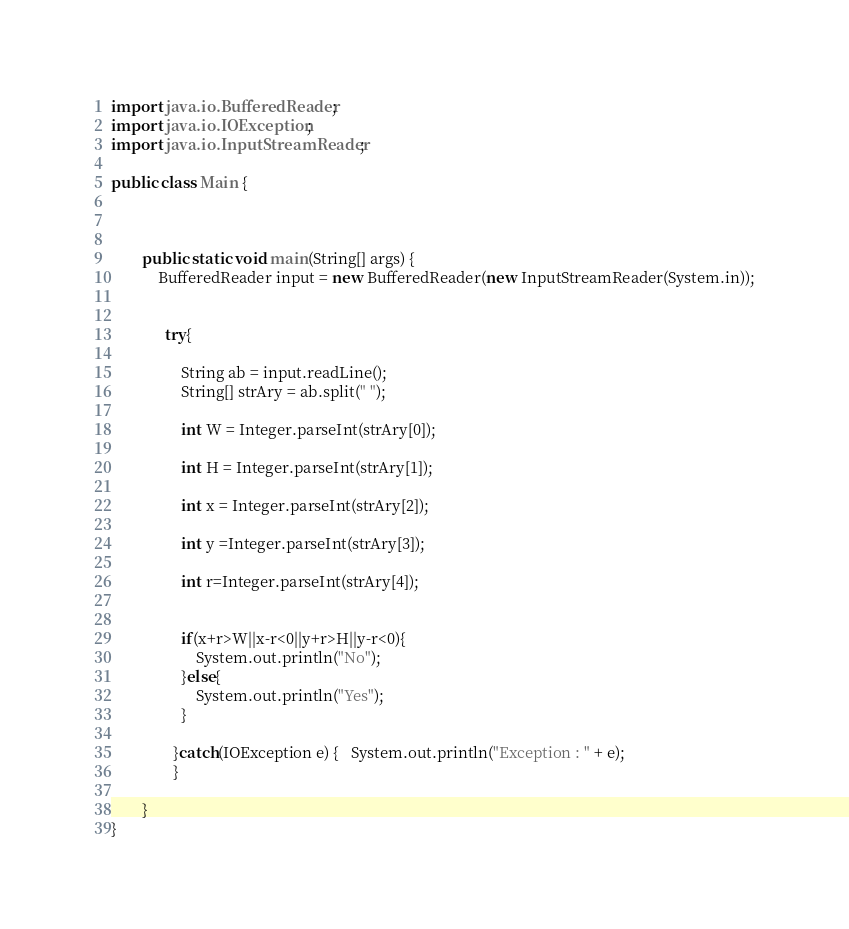Convert code to text. <code><loc_0><loc_0><loc_500><loc_500><_Java_>import java.io.BufferedReader;
import java.io.IOException;
import java.io.InputStreamReader;

public class Main {



		public static void main(String[] args) {
			BufferedReader input = new BufferedReader(new InputStreamReader(System.in));


			  try{
				  
				  String ab = input.readLine();
				  String[] strAry = ab.split(" ");

				  int W = Integer.parseInt(strAry[0]);
				 
				  int H = Integer.parseInt(strAry[1]);
				  
				  int x = Integer.parseInt(strAry[2]);
				  
				  int y =Integer.parseInt(strAry[3]);
				
				  int r=Integer.parseInt(strAry[4]);
				 

				  if(x+r>W||x-r<0||y+r>H||y-r<0){
					  System.out.println("No");
				  }else{
					  System.out.println("Yes");
				  }

			    }catch(IOException e) {   System.out.println("Exception : " + e);
			    }

		}
}</code> 